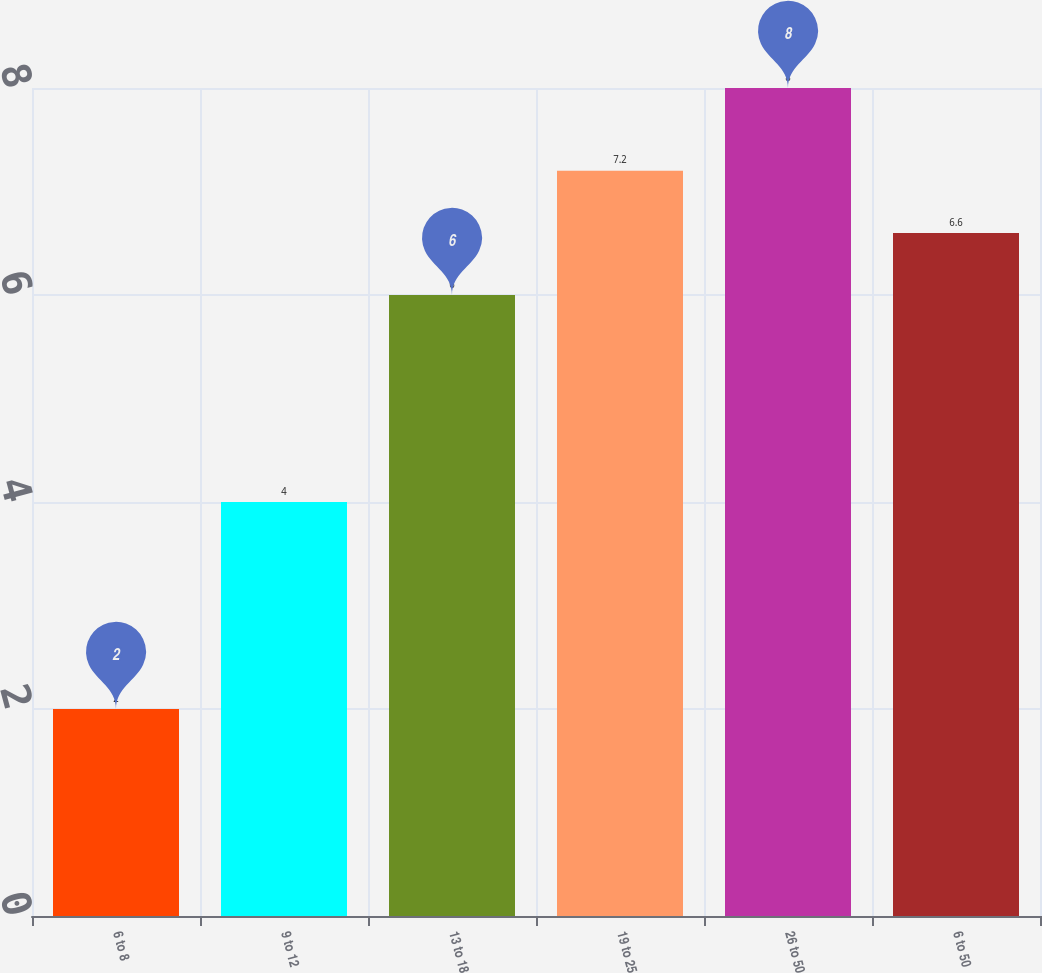Convert chart. <chart><loc_0><loc_0><loc_500><loc_500><bar_chart><fcel>6 to 8<fcel>9 to 12<fcel>13 to 18<fcel>19 to 25<fcel>26 to 50<fcel>6 to 50<nl><fcel>2<fcel>4<fcel>6<fcel>7.2<fcel>8<fcel>6.6<nl></chart> 